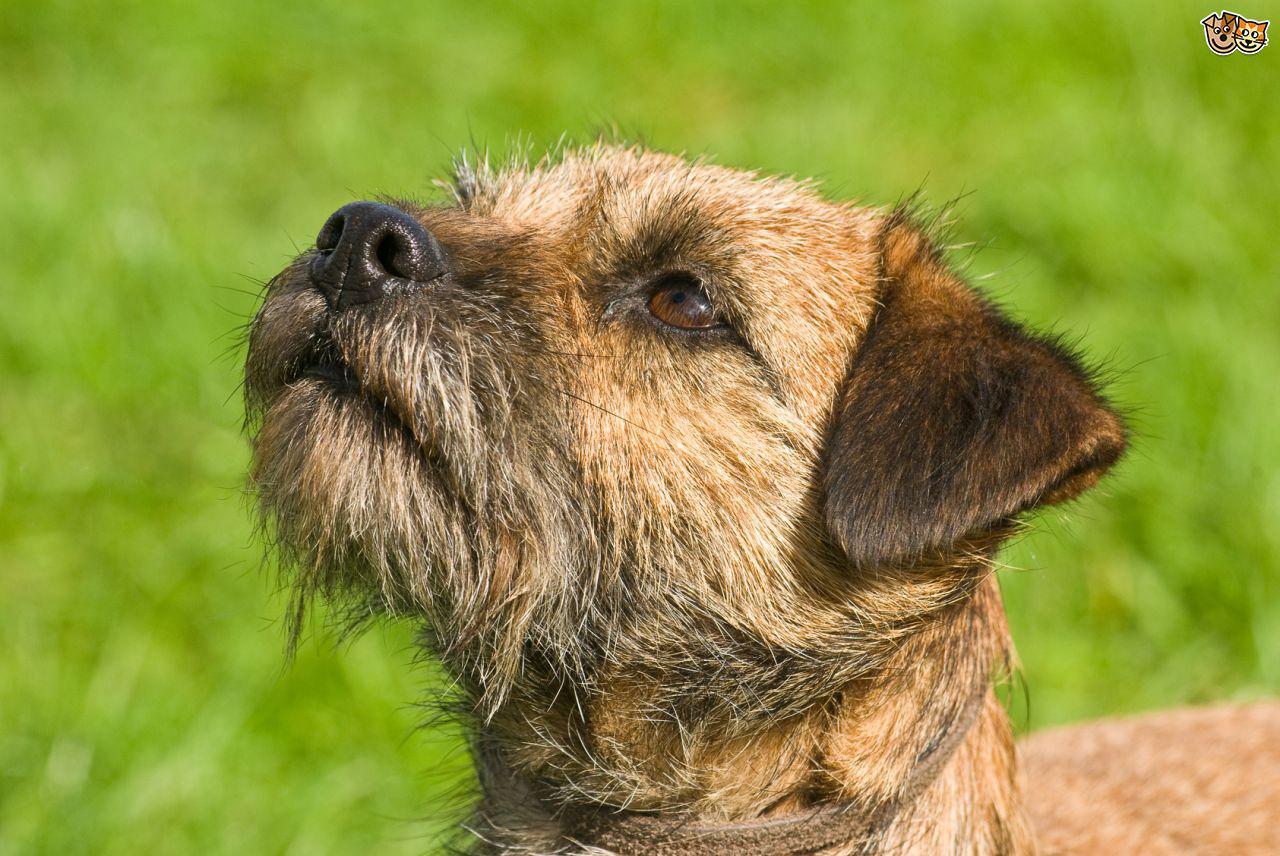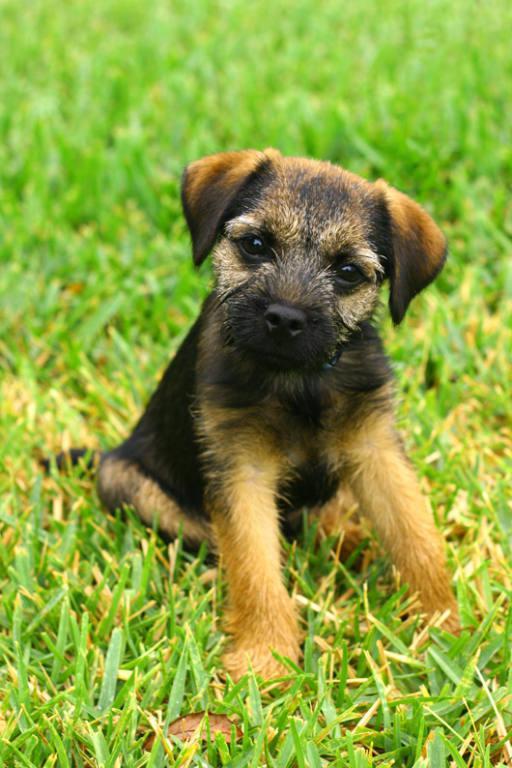The first image is the image on the left, the second image is the image on the right. Considering the images on both sides, is "The dog in the image on the right is not running." valid? Answer yes or no. Yes. The first image is the image on the left, the second image is the image on the right. Examine the images to the left and right. Is the description "Both images show a dog running in the grass." accurate? Answer yes or no. No. 